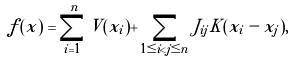<formula> <loc_0><loc_0><loc_500><loc_500>f ( x ) & = \sum _ { i = 1 } ^ { n } V ( x _ { i } ) + \sum _ { 1 \leq i < j \leq n } J _ { i j } K ( x _ { i } - x _ { j } ) ,</formula> 